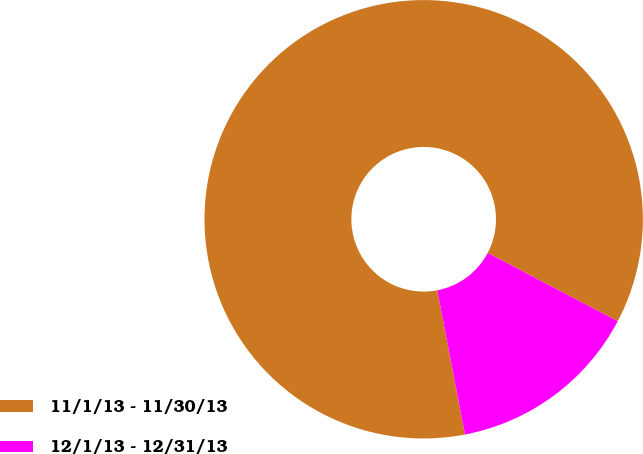Convert chart to OTSL. <chart><loc_0><loc_0><loc_500><loc_500><pie_chart><fcel>11/1/13 - 11/30/13<fcel>12/1/13 - 12/31/13<nl><fcel>85.71%<fcel>14.29%<nl></chart> 